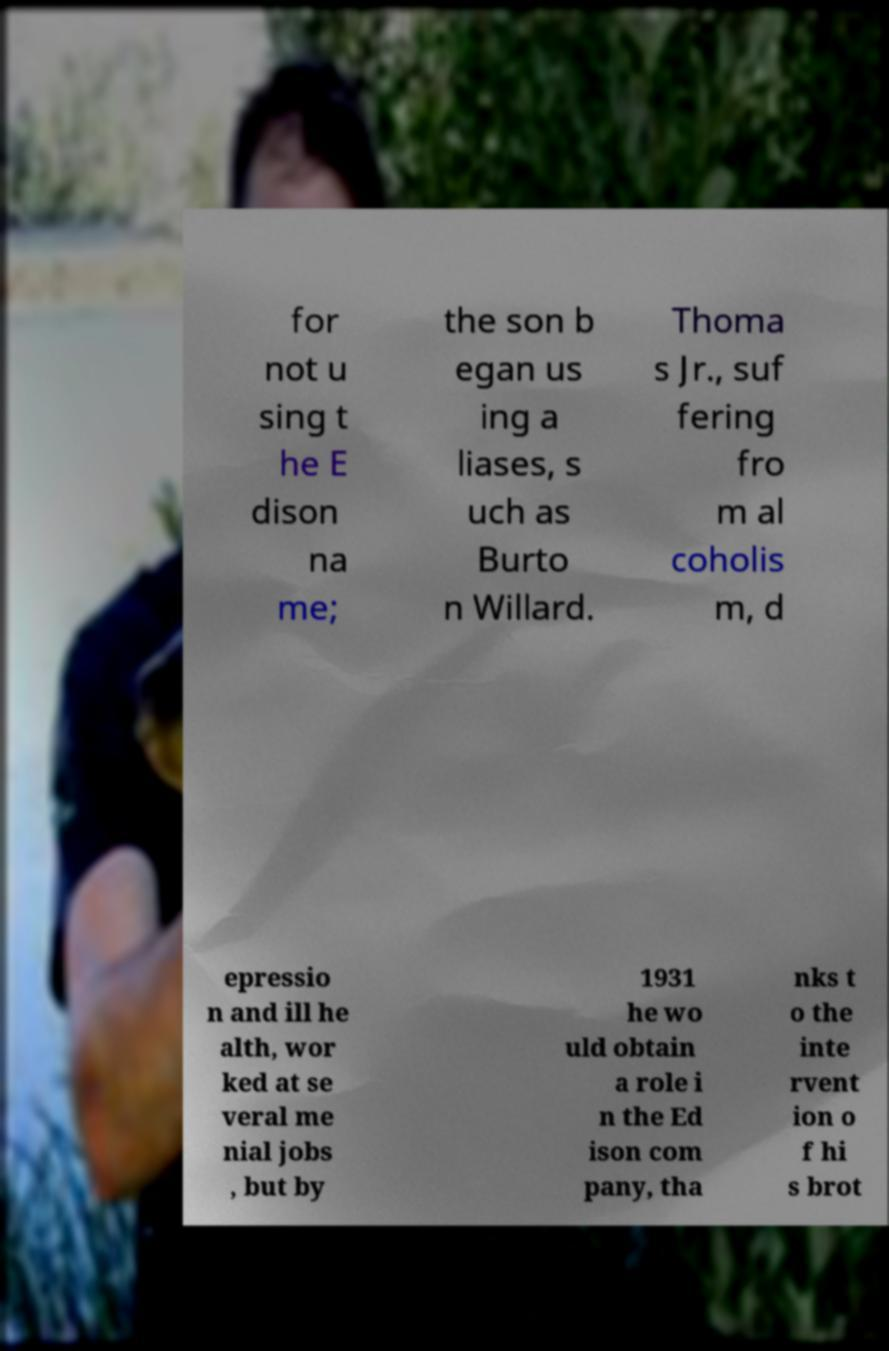Please read and relay the text visible in this image. What does it say? for not u sing t he E dison na me; the son b egan us ing a liases, s uch as Burto n Willard. Thoma s Jr., suf fering fro m al coholis m, d epressio n and ill he alth, wor ked at se veral me nial jobs , but by 1931 he wo uld obtain a role i n the Ed ison com pany, tha nks t o the inte rvent ion o f hi s brot 